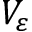Convert formula to latex. <formula><loc_0><loc_0><loc_500><loc_500>V _ { \varepsilon }</formula> 